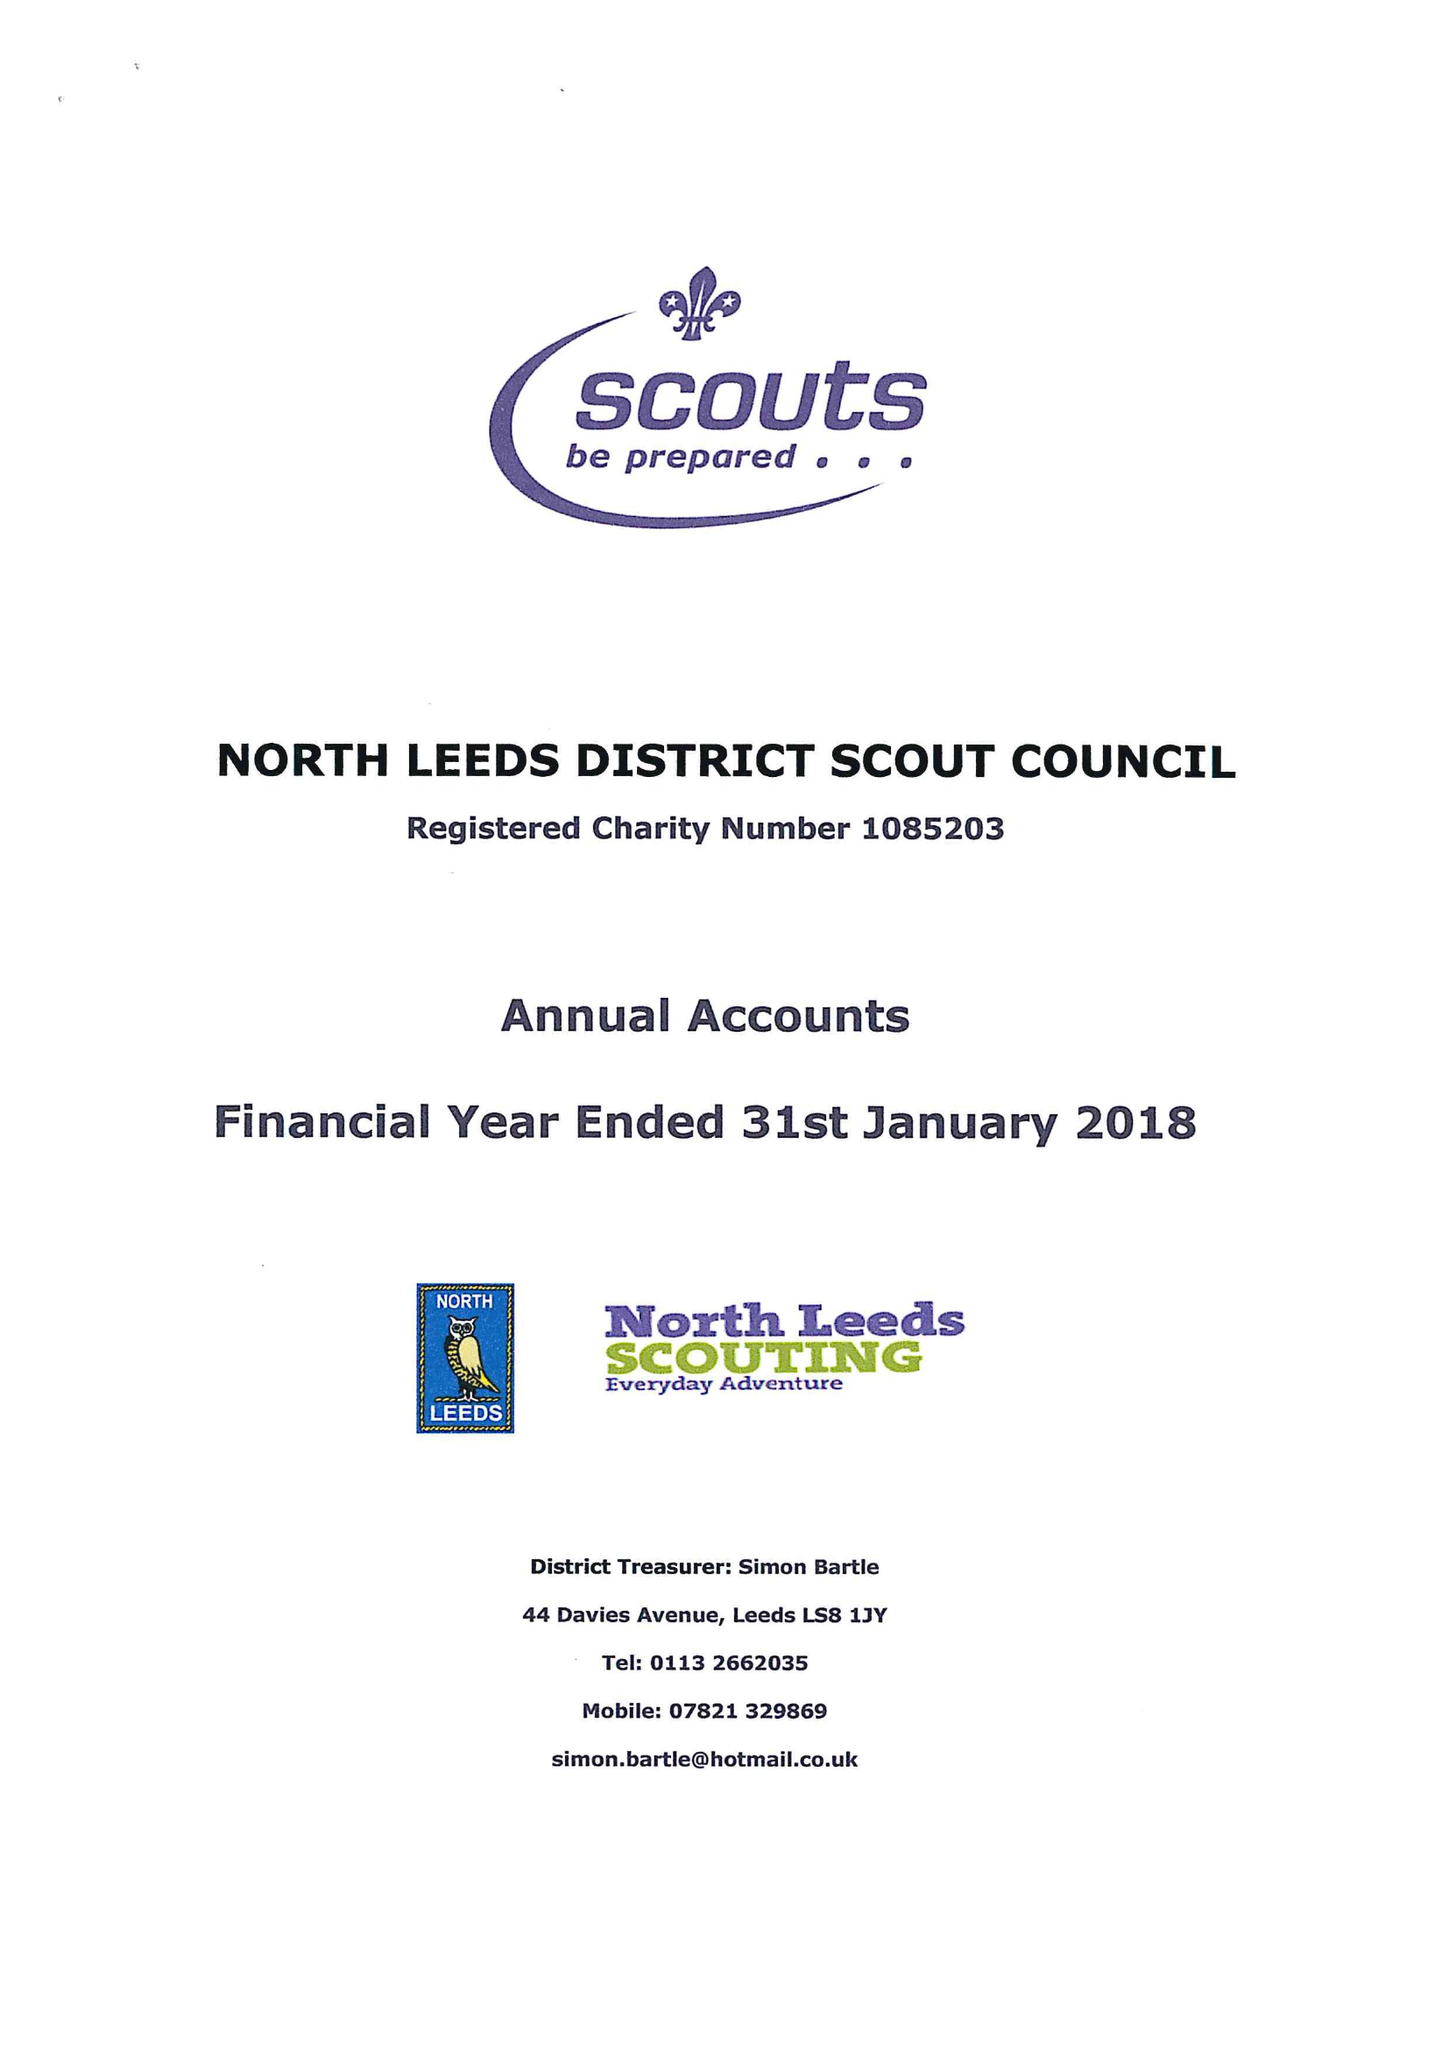What is the value for the report_date?
Answer the question using a single word or phrase. 2018-01-31 